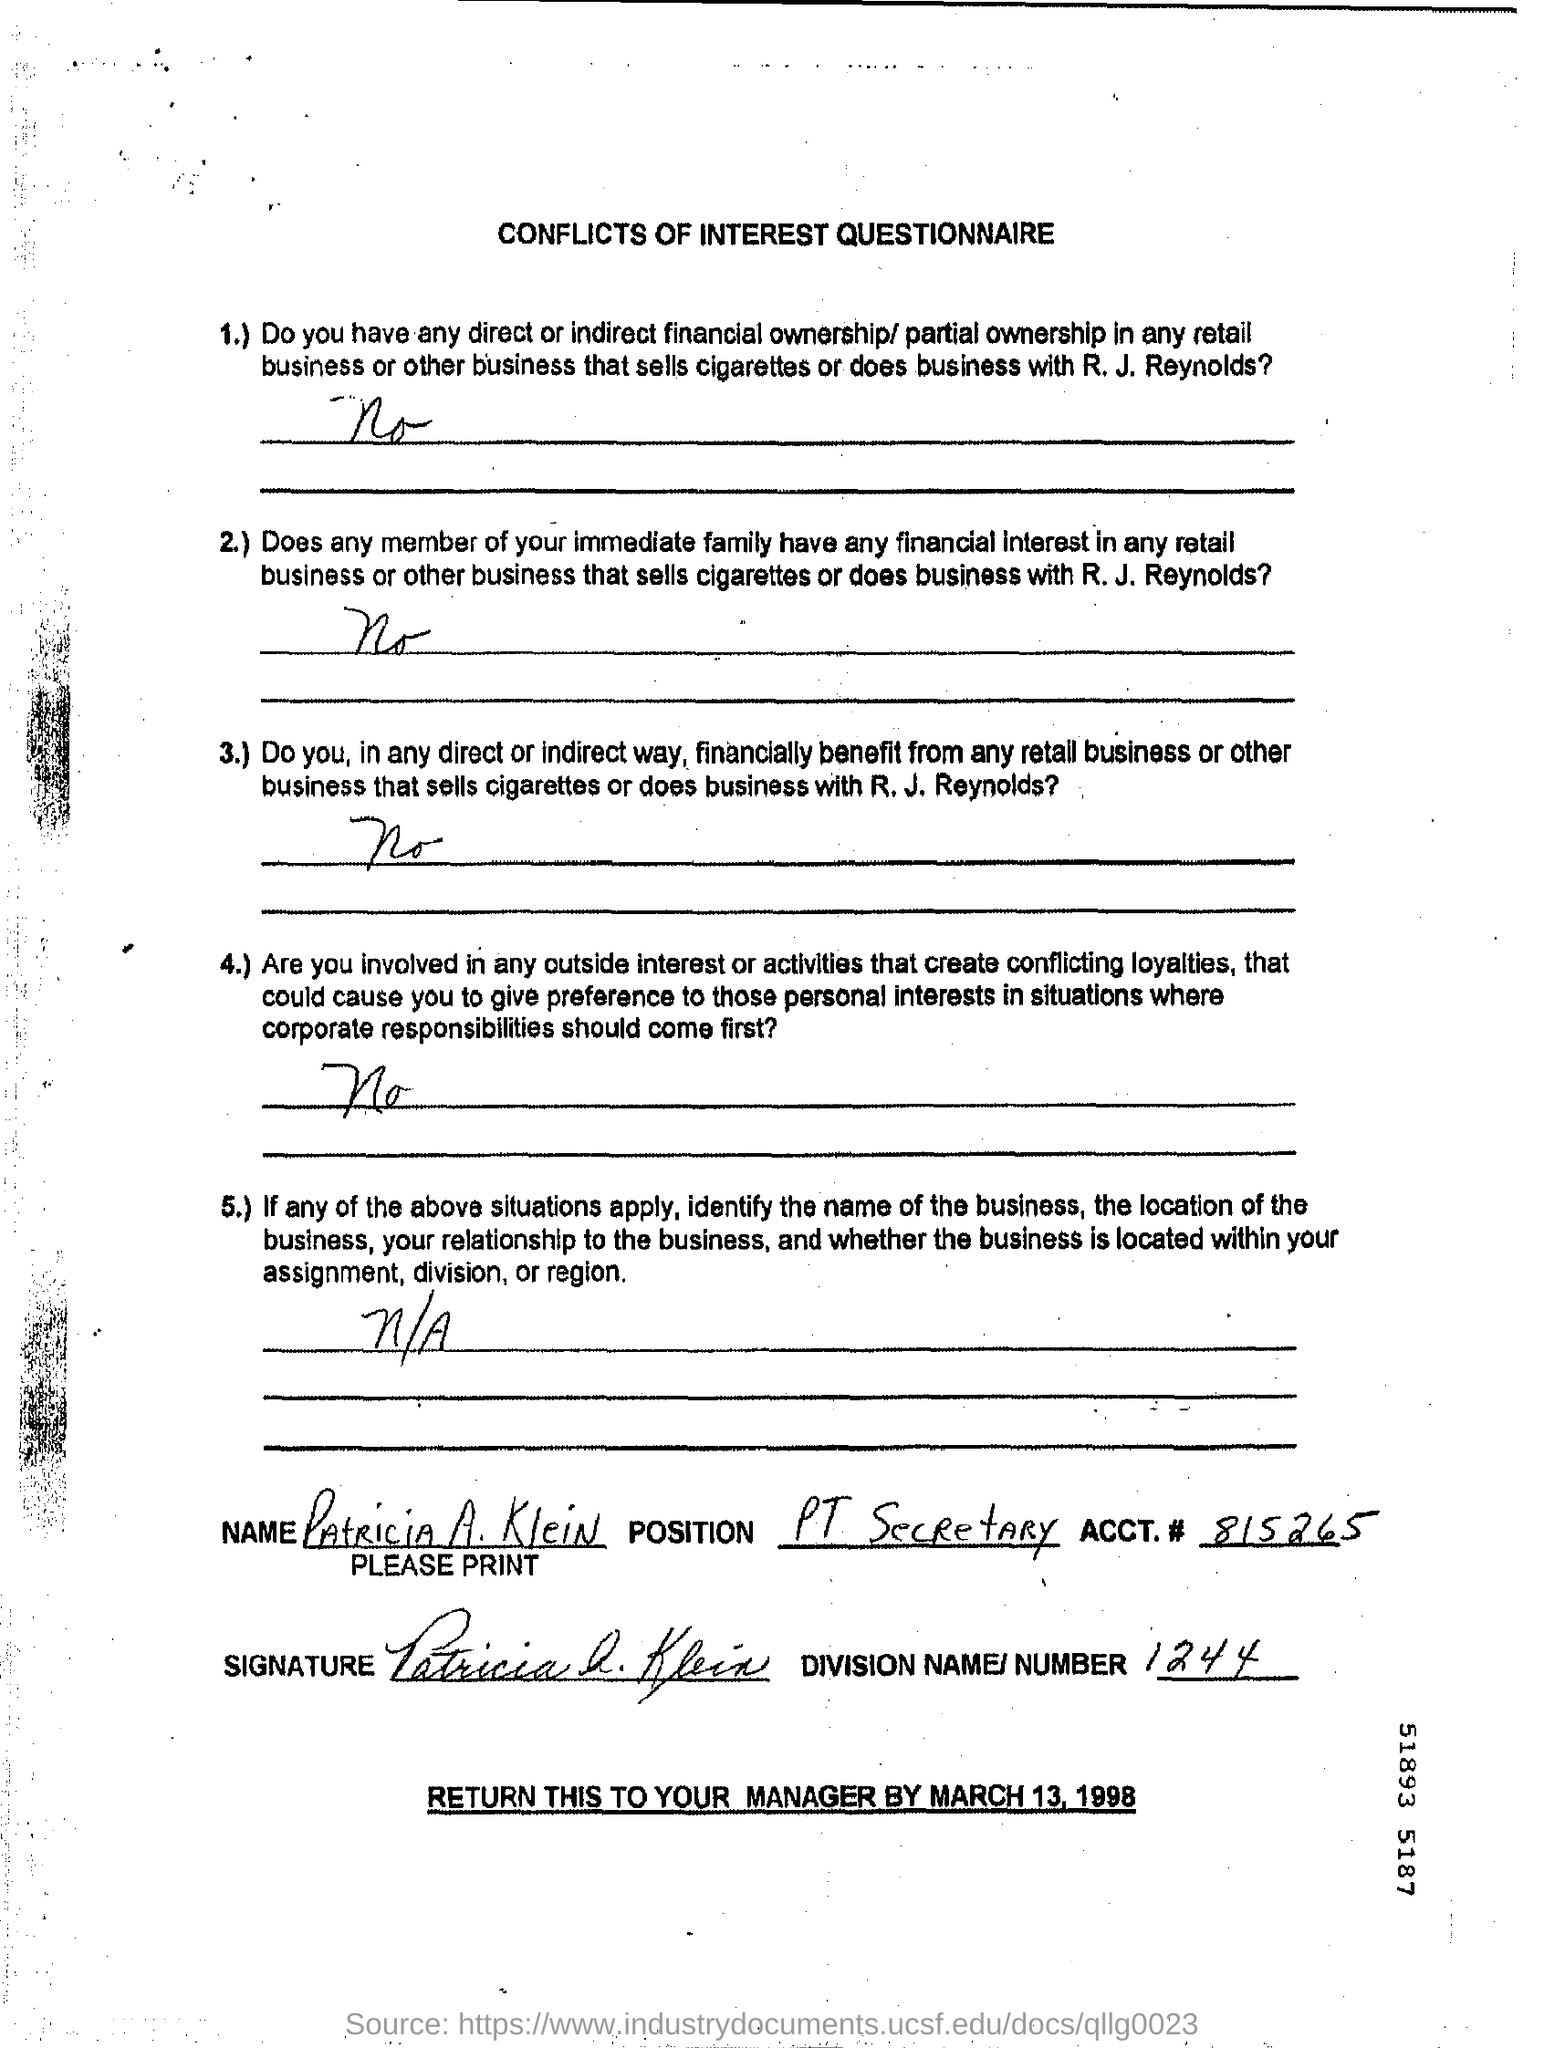What is the ACCT.# (no) given in the document?
Make the answer very short. 815265. What is the title of this document?
Ensure brevity in your answer.  CONFLICTS OF INTEREST QUESTIONNAIRE. What is the name mentioned in the document?
Ensure brevity in your answer.  PATRICIA A. KLEIN. What is the position of Patricia A. Klein?
Your response must be concise. PT Secretary. What is the Division number given?
Your answer should be very brief. 1244. When should be the document returned to the manager?
Keep it short and to the point. BY MARCH 13, 1998. 